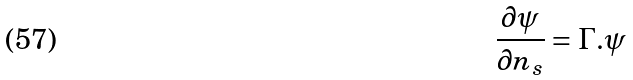Convert formula to latex. <formula><loc_0><loc_0><loc_500><loc_500>\frac { \partial \psi } { \partial n _ { s } } = \Gamma . \psi</formula> 